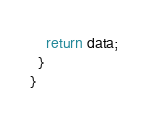Convert code to text. <code><loc_0><loc_0><loc_500><loc_500><_TypeScript_>    return data;
  }
}
</code> 